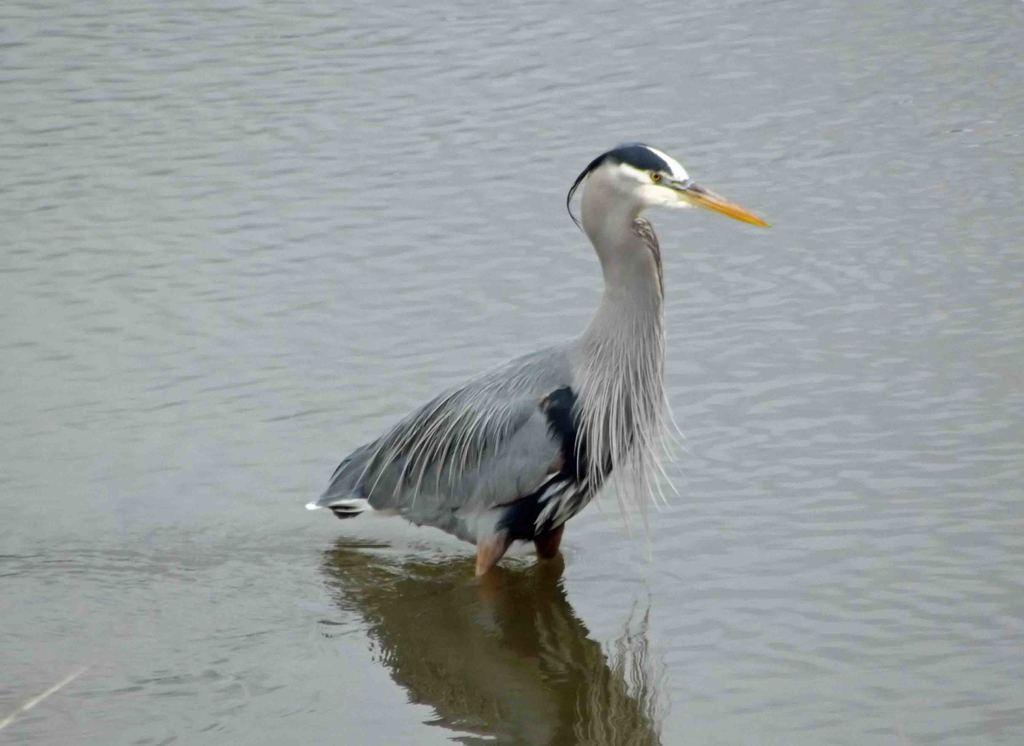What type of animal is in the water in the image? There is a bird in the water in the image. Can you describe the setting where the bird is located? The image is likely taken in a lake. What time of day might the image have been taken? The image was likely taken during the day. What type of hospital can be seen in the background of the image? There is no hospital present in the image; it features a bird in the water. Can you tell me how many bats are visible in the image? There are no bats present in the image. What type of chess piece is floating in the water in the image? There is no chess piece present in the image. 